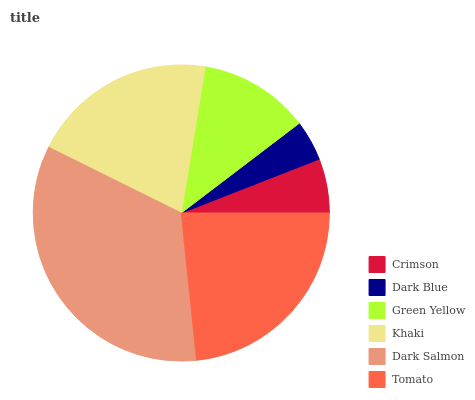Is Dark Blue the minimum?
Answer yes or no. Yes. Is Dark Salmon the maximum?
Answer yes or no. Yes. Is Green Yellow the minimum?
Answer yes or no. No. Is Green Yellow the maximum?
Answer yes or no. No. Is Green Yellow greater than Dark Blue?
Answer yes or no. Yes. Is Dark Blue less than Green Yellow?
Answer yes or no. Yes. Is Dark Blue greater than Green Yellow?
Answer yes or no. No. Is Green Yellow less than Dark Blue?
Answer yes or no. No. Is Khaki the high median?
Answer yes or no. Yes. Is Green Yellow the low median?
Answer yes or no. Yes. Is Dark Blue the high median?
Answer yes or no. No. Is Crimson the low median?
Answer yes or no. No. 